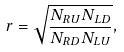<formula> <loc_0><loc_0><loc_500><loc_500>r = \sqrt { \frac { N _ { R U } N _ { L D } } { N _ { R D } N _ { L U } } } ,</formula> 